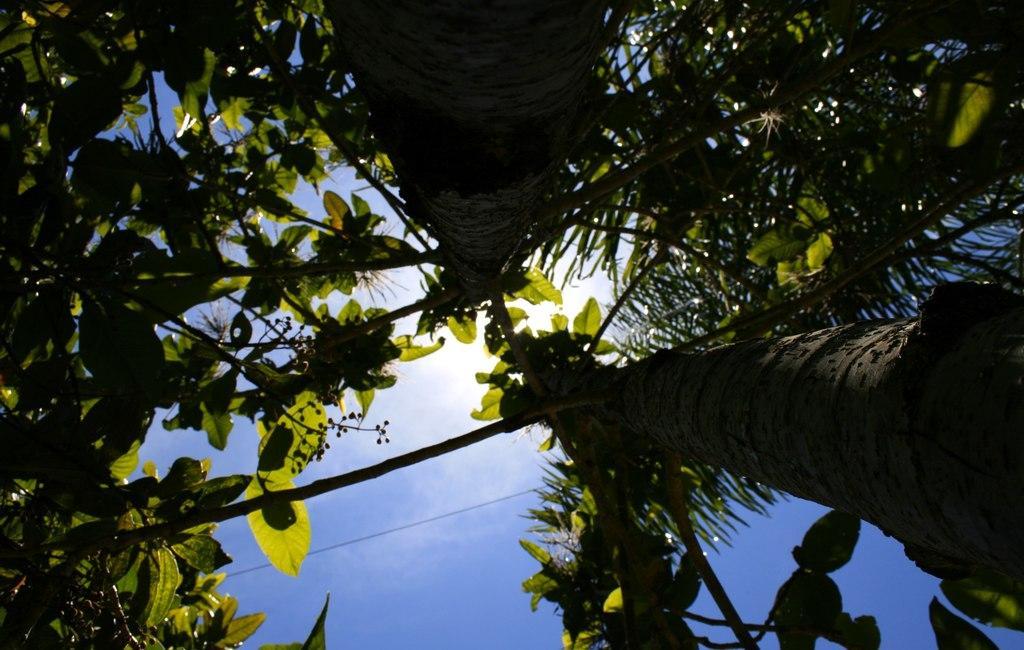Can you describe this image briefly? In this image we can see few trees, sun and the sky. 